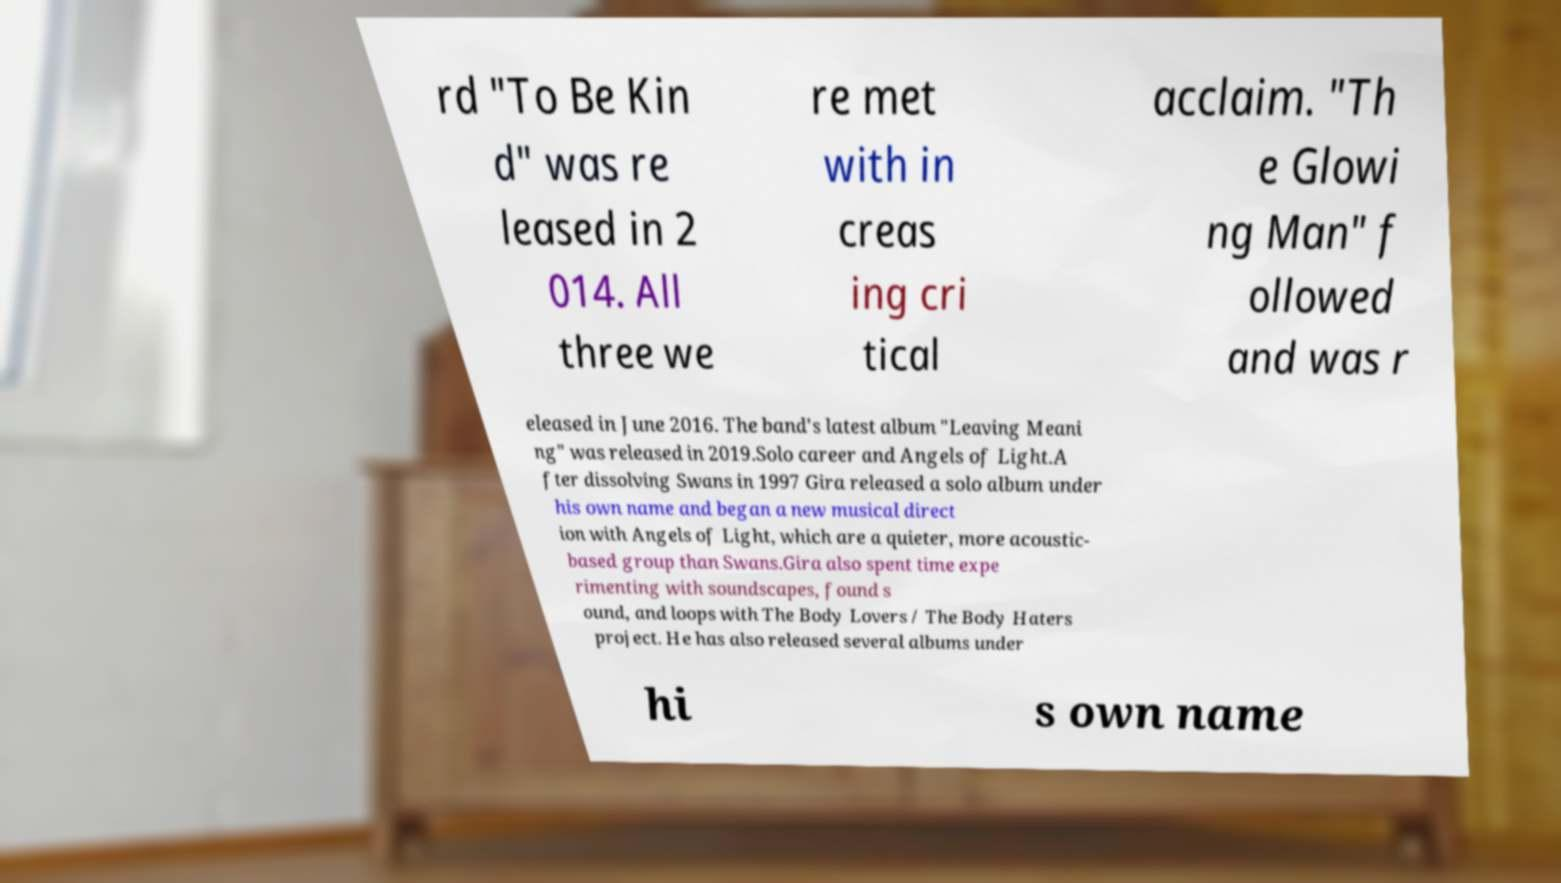Can you read and provide the text displayed in the image?This photo seems to have some interesting text. Can you extract and type it out for me? rd "To Be Kin d" was re leased in 2 014. All three we re met with in creas ing cri tical acclaim. "Th e Glowi ng Man" f ollowed and was r eleased in June 2016. The band's latest album "Leaving Meani ng" was released in 2019.Solo career and Angels of Light.A fter dissolving Swans in 1997 Gira released a solo album under his own name and began a new musical direct ion with Angels of Light, which are a quieter, more acoustic- based group than Swans.Gira also spent time expe rimenting with soundscapes, found s ound, and loops with The Body Lovers / The Body Haters project. He has also released several albums under hi s own name 